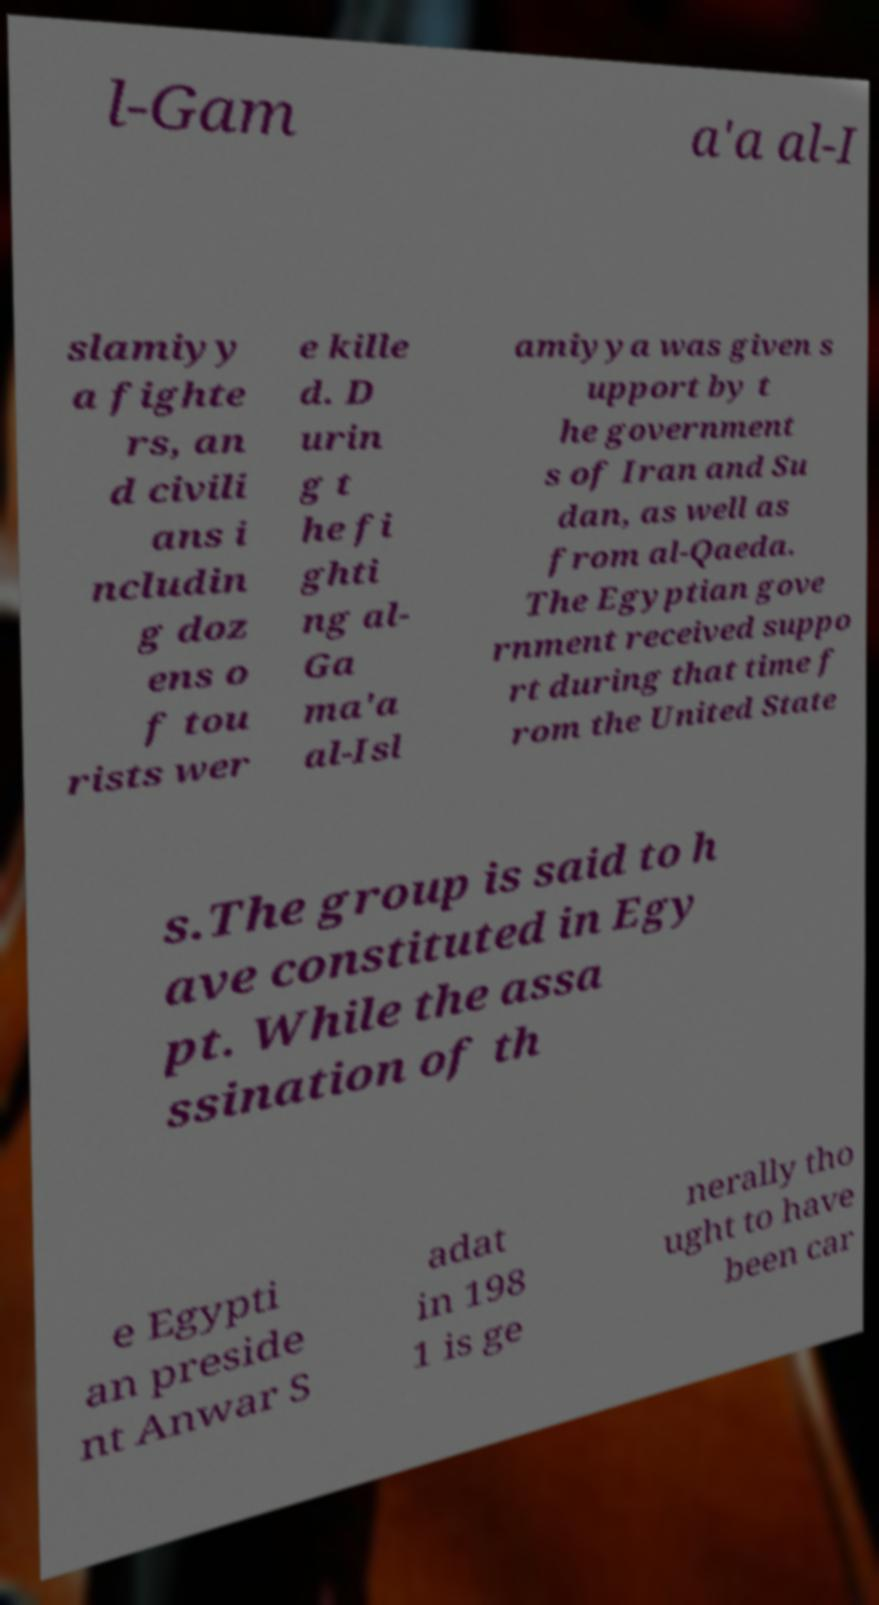Could you assist in decoding the text presented in this image and type it out clearly? l-Gam a'a al-I slamiyy a fighte rs, an d civili ans i ncludin g doz ens o f tou rists wer e kille d. D urin g t he fi ghti ng al- Ga ma'a al-Isl amiyya was given s upport by t he government s of Iran and Su dan, as well as from al-Qaeda. The Egyptian gove rnment received suppo rt during that time f rom the United State s.The group is said to h ave constituted in Egy pt. While the assa ssination of th e Egypti an preside nt Anwar S adat in 198 1 is ge nerally tho ught to have been car 